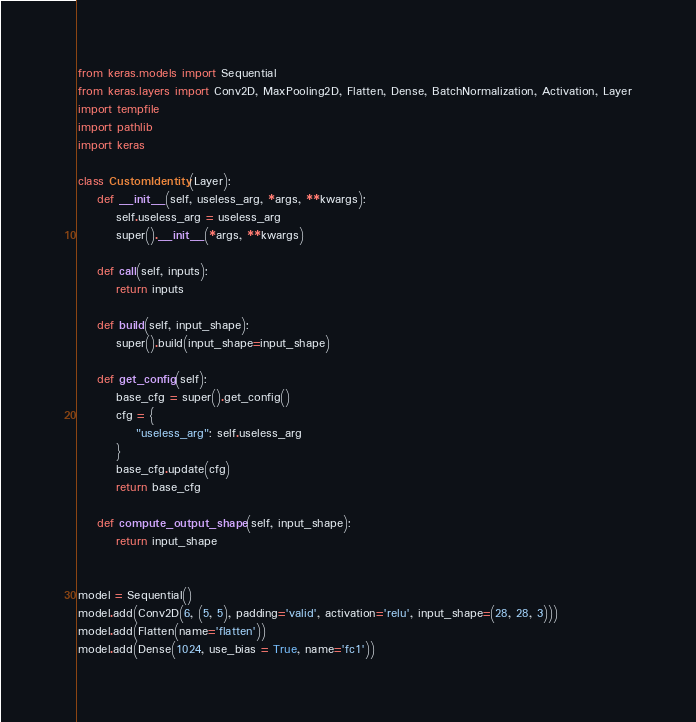<code> <loc_0><loc_0><loc_500><loc_500><_Python_>from keras.models import Sequential
from keras.layers import Conv2D, MaxPooling2D, Flatten, Dense, BatchNormalization, Activation, Layer
import tempfile
import pathlib
import keras

class CustomIdentity(Layer):
    def __init__(self, useless_arg, *args, **kwargs):
        self.useless_arg = useless_arg
        super().__init__(*args, **kwargs)

    def call(self, inputs):
        return inputs

    def build(self, input_shape):
        super().build(input_shape=input_shape)

    def get_config(self):
        base_cfg = super().get_config()
        cfg = {
            "useless_arg": self.useless_arg
        }
        base_cfg.update(cfg)
        return base_cfg

    def compute_output_shape(self, input_shape):
        return input_shape


model = Sequential()
model.add(Conv2D(6, (5, 5), padding='valid', activation='relu', input_shape=(28, 28, 3)))
model.add(Flatten(name='flatten'))
model.add(Dense(1024, use_bias = True, name='fc1'))</code> 